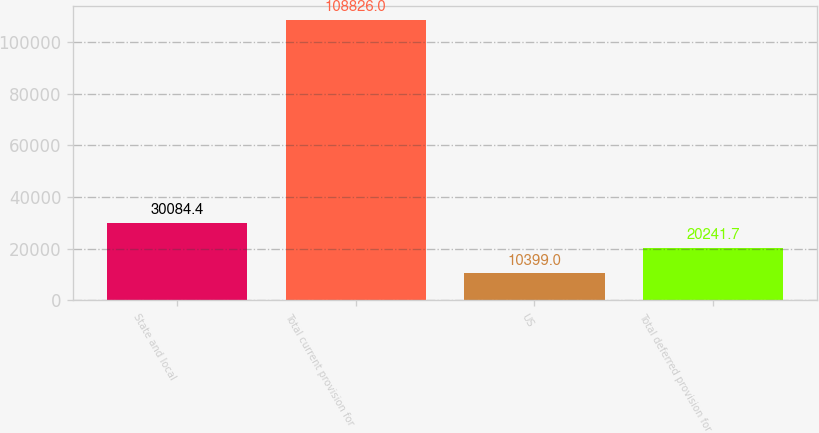Convert chart. <chart><loc_0><loc_0><loc_500><loc_500><bar_chart><fcel>State and local<fcel>Total current provision for<fcel>US<fcel>Total deferred provision for<nl><fcel>30084.4<fcel>108826<fcel>10399<fcel>20241.7<nl></chart> 